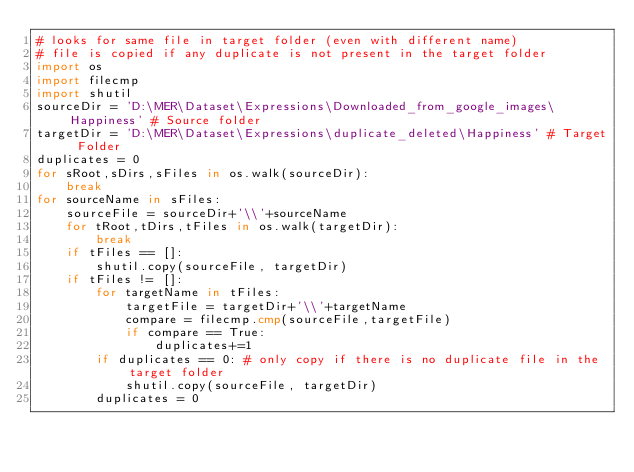Convert code to text. <code><loc_0><loc_0><loc_500><loc_500><_Python_># looks for same file in target folder (even with different name)
# file is copied if any duplicate is not present in the target folder
import os
import filecmp
import shutil
sourceDir = 'D:\MER\Dataset\Expressions\Downloaded_from_google_images\Happiness' # Source folder
targetDir = 'D:\MER\Dataset\Expressions\duplicate_deleted\Happiness' # Target Folder
duplicates = 0
for sRoot,sDirs,sFiles in os.walk(sourceDir):
    break
for sourceName in sFiles:
    sourceFile = sourceDir+'\\'+sourceName
    for tRoot,tDirs,tFiles in os.walk(targetDir):
        break
    if tFiles == []:
        shutil.copy(sourceFile, targetDir)
    if tFiles != []:
        for targetName in tFiles:
            targetFile = targetDir+'\\'+targetName
            compare = filecmp.cmp(sourceFile,targetFile)
            if compare == True:
                duplicates+=1
        if duplicates == 0: # only copy if there is no duplicate file in the target folder
            shutil.copy(sourceFile, targetDir)
        duplicates = 0
</code> 